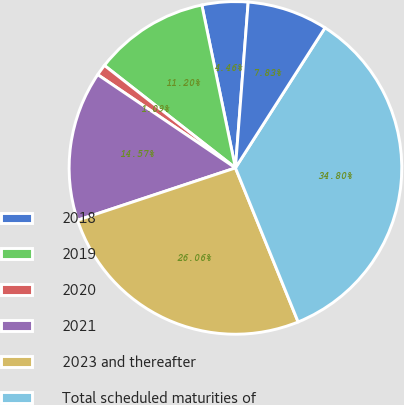Convert chart. <chart><loc_0><loc_0><loc_500><loc_500><pie_chart><fcel>2018<fcel>2019<fcel>2020<fcel>2021<fcel>2023 and thereafter<fcel>Total scheduled maturities of<fcel>Current maturities of long<nl><fcel>4.46%<fcel>11.2%<fcel>1.09%<fcel>14.57%<fcel>26.06%<fcel>34.8%<fcel>7.83%<nl></chart> 